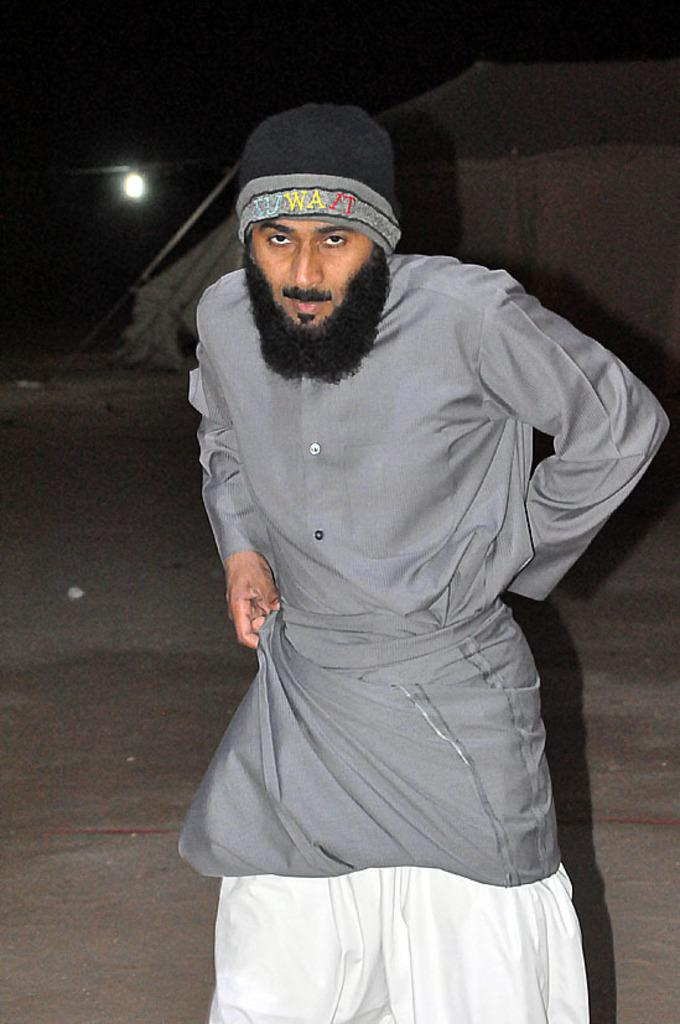What is the main subject of the image? There is a person standing in the image. Can you describe the person's clothing? The person is wearing a cap and a grey shirt. What is a noticeable feature of the person's appearance? The person has a beard. Where is the light source coming from in the image? The light source is at the back of the person. What color is the person's sock in the image? There is no mention of a sock in the image, so we cannot determine its color. 